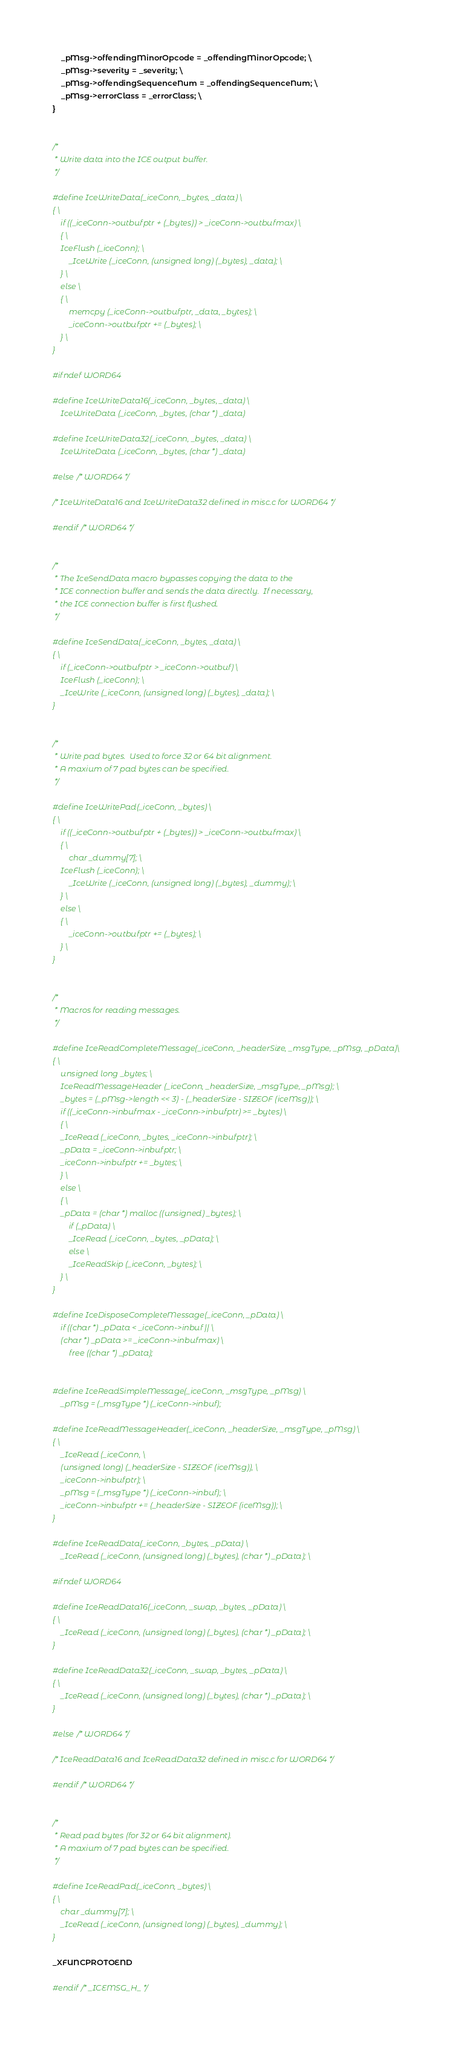<code> <loc_0><loc_0><loc_500><loc_500><_C_>    _pMsg->offendingMinorOpcode = _offendingMinorOpcode; \
    _pMsg->severity = _severity; \
    _pMsg->offendingSequenceNum = _offendingSequenceNum; \
    _pMsg->errorClass = _errorClass; \
}


/*
 * Write data into the ICE output buffer.
 */

#define IceWriteData(_iceConn, _bytes, _data) \
{ \
    if ((_iceConn->outbufptr + (_bytes)) > _iceConn->outbufmax) \
    { \
	IceFlush (_iceConn); \
        _IceWrite (_iceConn, (unsigned long) (_bytes), _data); \
    } \
    else \
    { \
        memcpy (_iceConn->outbufptr, _data, _bytes); \
        _iceConn->outbufptr += (_bytes); \
    } \
}

#ifndef WORD64

#define IceWriteData16(_iceConn, _bytes, _data) \
    IceWriteData (_iceConn, _bytes, (char *) _data)

#define IceWriteData32(_iceConn, _bytes, _data) \
    IceWriteData (_iceConn, _bytes, (char *) _data)

#else /* WORD64 */

/* IceWriteData16 and IceWriteData32 defined in misc.c for WORD64 */

#endif /* WORD64 */


/*
 * The IceSendData macro bypasses copying the data to the
 * ICE connection buffer and sends the data directly.  If necessary,
 * the ICE connection buffer is first flushed.
 */

#define IceSendData(_iceConn, _bytes, _data) \
{ \
    if (_iceConn->outbufptr > _iceConn->outbuf) \
	IceFlush (_iceConn); \
    _IceWrite (_iceConn, (unsigned long) (_bytes), _data); \
}


/*
 * Write pad bytes.  Used to force 32 or 64 bit alignment.
 * A maxium of 7 pad bytes can be specified.
 */

#define IceWritePad(_iceConn, _bytes) \
{ \
    if ((_iceConn->outbufptr + (_bytes)) > _iceConn->outbufmax) \
    { \
        char _dummy[7]; \
	IceFlush (_iceConn); \
        _IceWrite (_iceConn, (unsigned long) (_bytes), _dummy); \
    } \
    else \
    { \
        _iceConn->outbufptr += (_bytes); \
    } \
}


/*
 * Macros for reading messages.
 */

#define IceReadCompleteMessage(_iceConn, _headerSize, _msgType, _pMsg, _pData)\
{ \
    unsigned long _bytes; \
    IceReadMessageHeader (_iceConn, _headerSize, _msgType, _pMsg); \
    _bytes = (_pMsg->length << 3) - (_headerSize - SIZEOF (iceMsg)); \
    if ((_iceConn->inbufmax - _iceConn->inbufptr) >= _bytes) \
    { \
	_IceRead (_iceConn, _bytes, _iceConn->inbufptr); \
	_pData = _iceConn->inbufptr; \
	_iceConn->inbufptr += _bytes; \
    } \
    else \
    { \
	_pData = (char *) malloc ((unsigned) _bytes); \
        if (_pData) \
	    _IceRead (_iceConn, _bytes, _pData); \
        else \
	    _IceReadSkip (_iceConn, _bytes); \
    } \
}

#define IceDisposeCompleteMessage(_iceConn, _pData) \
    if ((char *) _pData < _iceConn->inbuf || \
	(char *) _pData >= _iceConn->inbufmax) \
        free ((char *) _pData);


#define IceReadSimpleMessage(_iceConn, _msgType, _pMsg) \
    _pMsg = (_msgType *) (_iceConn->inbuf);

#define IceReadMessageHeader(_iceConn, _headerSize, _msgType, _pMsg) \
{ \
    _IceRead (_iceConn, \
	(unsigned long) (_headerSize - SIZEOF (iceMsg)), \
	_iceConn->inbufptr); \
    _pMsg = (_msgType *) (_iceConn->inbuf); \
    _iceConn->inbufptr += (_headerSize - SIZEOF (iceMsg)); \
}

#define IceReadData(_iceConn, _bytes, _pData) \
    _IceRead (_iceConn, (unsigned long) (_bytes), (char *) _pData); \

#ifndef WORD64

#define IceReadData16(_iceConn, _swap, _bytes, _pData) \
{ \
    _IceRead (_iceConn, (unsigned long) (_bytes), (char *) _pData); \
}

#define IceReadData32(_iceConn, _swap, _bytes, _pData) \
{ \
    _IceRead (_iceConn, (unsigned long) (_bytes), (char *) _pData); \
}

#else /* WORD64 */

/* IceReadData16 and IceReadData32 defined in misc.c for WORD64 */

#endif /* WORD64 */


/*
 * Read pad bytes (for 32 or 64 bit alignment).
 * A maxium of 7 pad bytes can be specified.
 */

#define IceReadPad(_iceConn, _bytes) \
{ \
    char _dummy[7]; \
    _IceRead (_iceConn, (unsigned long) (_bytes), _dummy); \
}

_XFUNCPROTOEND

#endif /* _ICEMSG_H_ */
</code> 